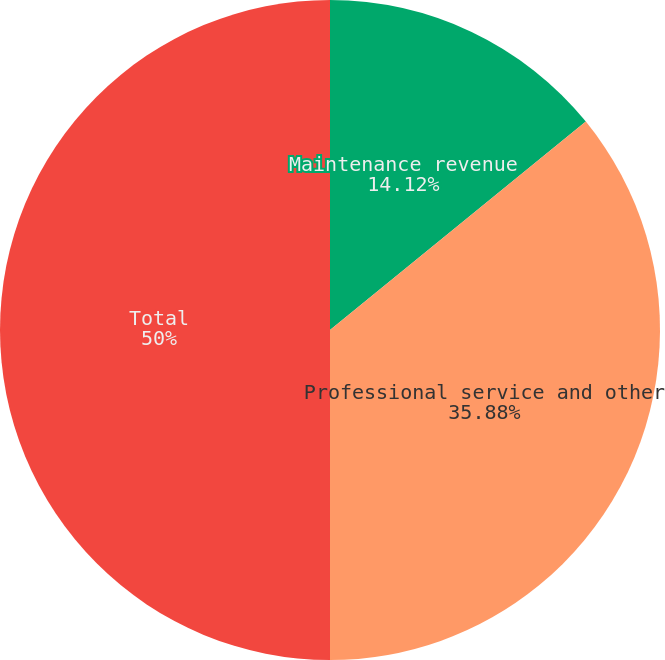Convert chart to OTSL. <chart><loc_0><loc_0><loc_500><loc_500><pie_chart><fcel>Maintenance revenue<fcel>Professional service and other<fcel>Total<nl><fcel>14.12%<fcel>35.88%<fcel>50.0%<nl></chart> 